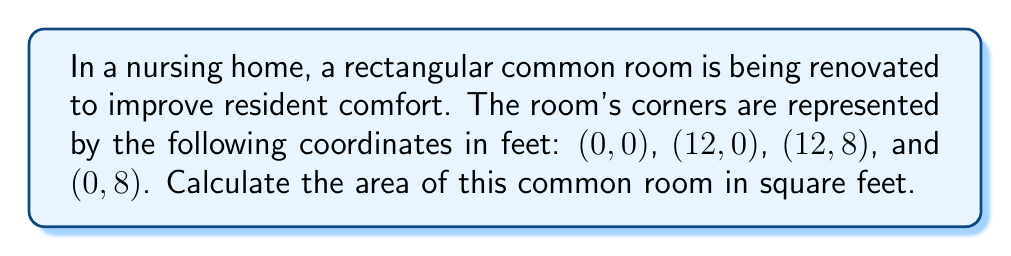Can you solve this math problem? Let's approach this step-by-step:

1) The room is rectangular, so we can use the formula for the area of a rectangle:

   $$ A = l \times w $$

   where $A$ is the area, $l$ is the length, and $w$ is the width.

2) To find the length and width, we need to calculate the distances between the coordinates:

   Length: from (0, 0) to (12, 0)
   Width: from (0, 0) to (0, 8)

3) For the length:
   $$ l = |x_2 - x_1| = |12 - 0| = 12 \text{ feet} $$

4) For the width:
   $$ w = |y_2 - y_1| = |8 - 0| = 8 \text{ feet} $$

5) Now we can calculate the area:
   $$ A = l \times w = 12 \times 8 = 96 \text{ square feet} $$

[asy]
unitsize(0.5cm);
draw((0,0)--(12,0)--(12,8)--(0,8)--cycle);
label("(0,0)", (0,0), SW);
label("(12,0)", (12,0), SE);
label("(12,8)", (12,8), NE);
label("(0,8)", (0,8), NW);
label("12 feet", (6,0), S);
label("8 feet", (0,4), W);
[/asy]
Answer: 96 square feet 